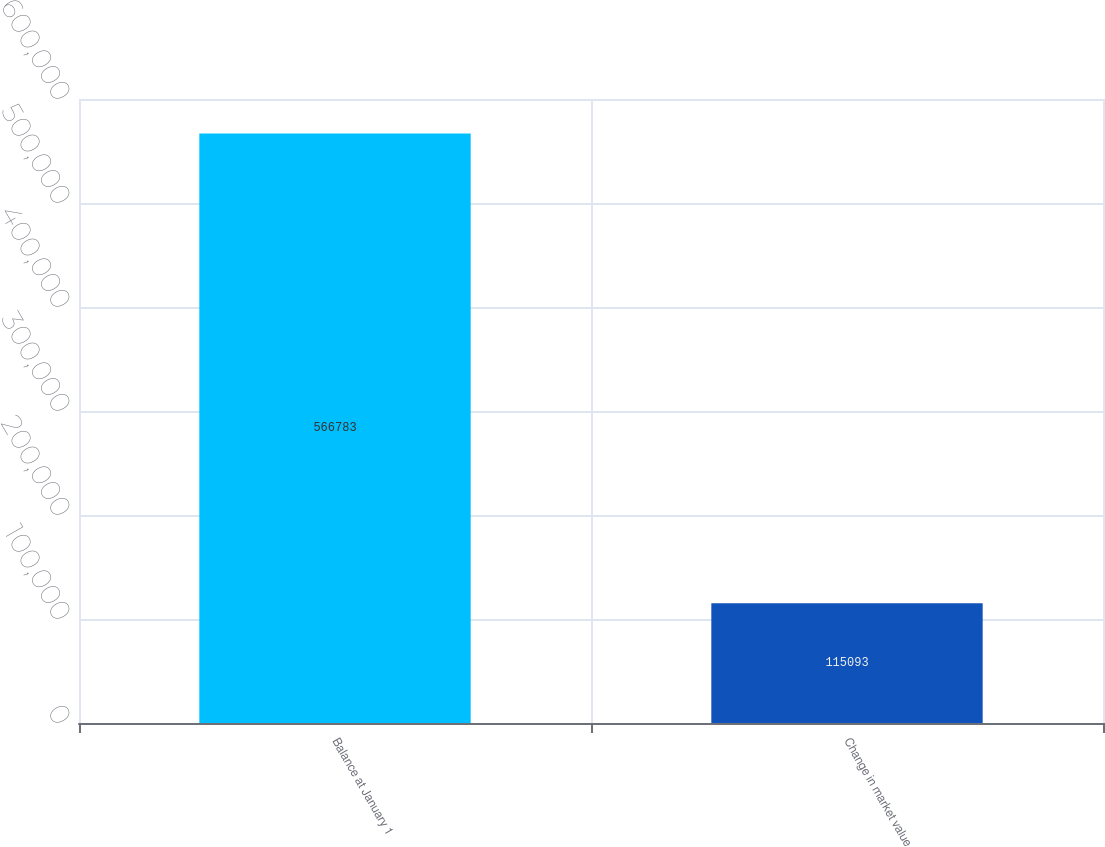Convert chart to OTSL. <chart><loc_0><loc_0><loc_500><loc_500><bar_chart><fcel>Balance at January 1<fcel>Change in market value<nl><fcel>566783<fcel>115093<nl></chart> 